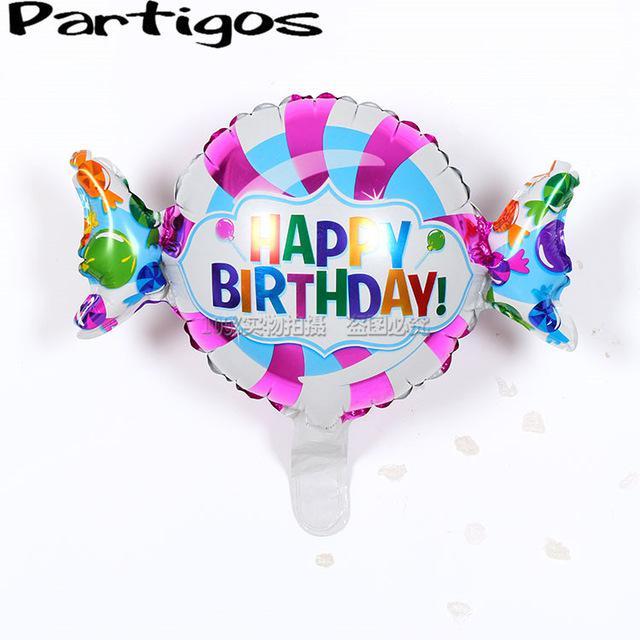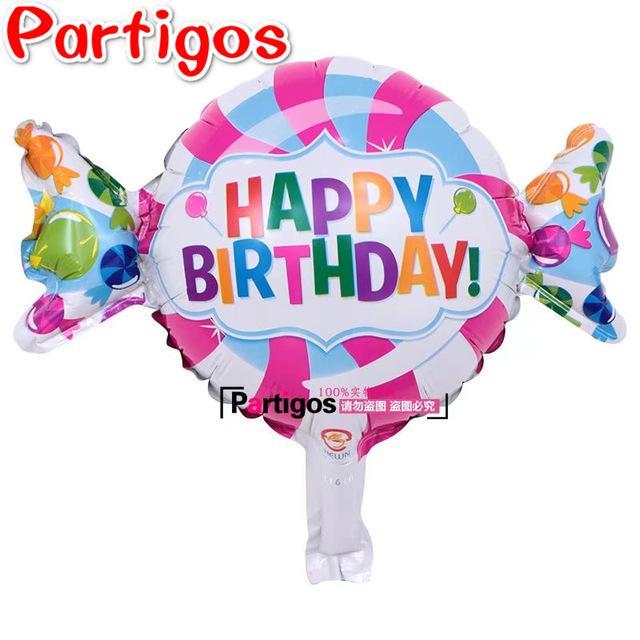The first image is the image on the left, the second image is the image on the right. Analyze the images presented: Is the assertion "There are no more than seven balloons with at least one looking like a piece of wrapped candy." valid? Answer yes or no. Yes. The first image is the image on the left, the second image is the image on the right. Assess this claim about the two images: "There is a single balloon in the left image.". Correct or not? Answer yes or no. Yes. 